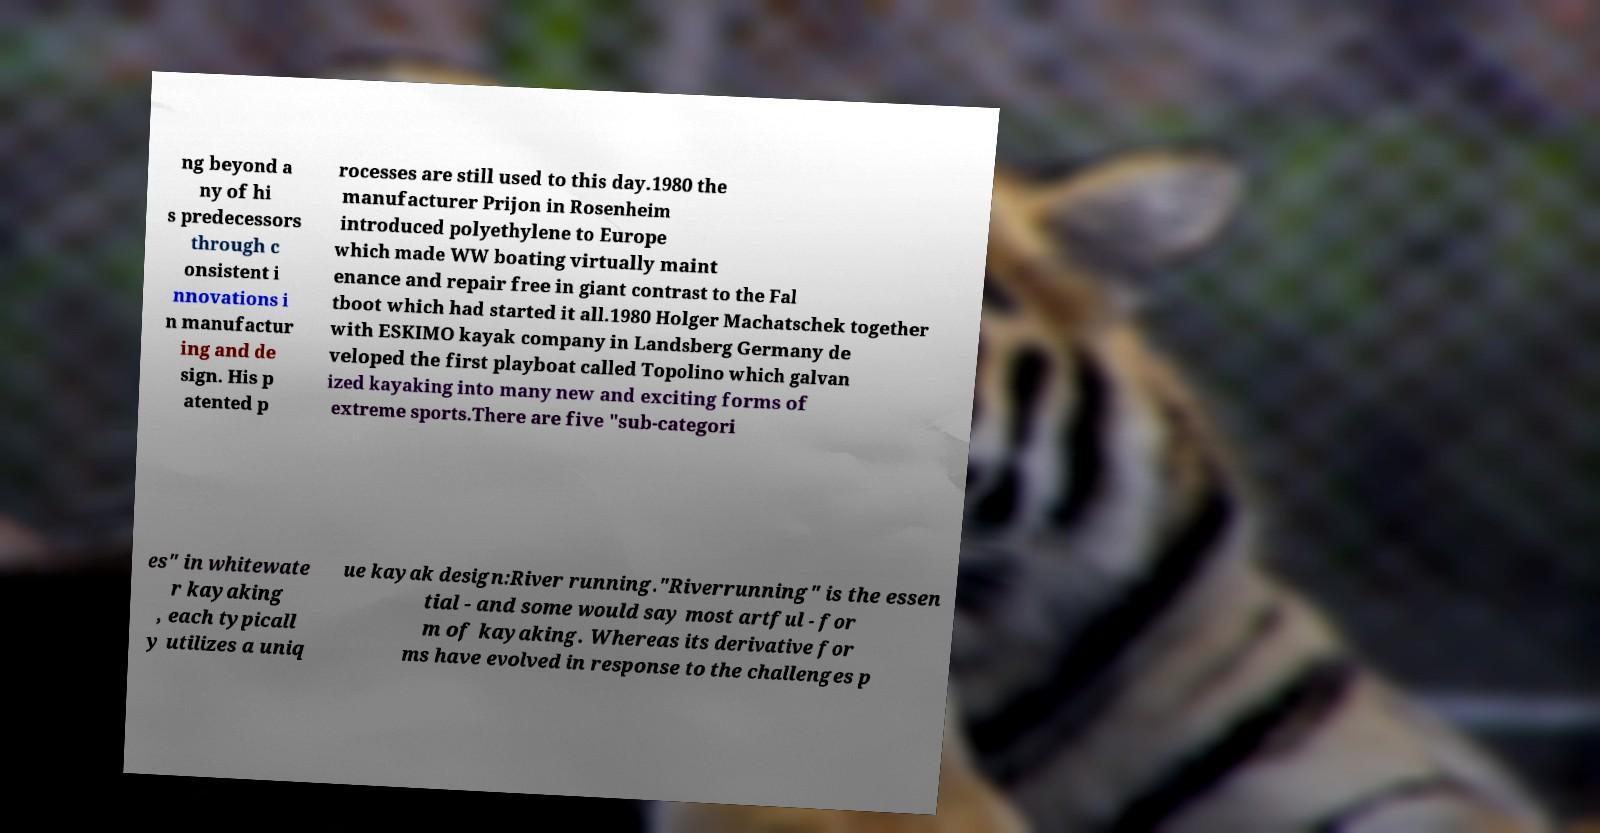What messages or text are displayed in this image? I need them in a readable, typed format. ng beyond a ny of hi s predecessors through c onsistent i nnovations i n manufactur ing and de sign. His p atented p rocesses are still used to this day.1980 the manufacturer Prijon in Rosenheim introduced polyethylene to Europe which made WW boating virtually maint enance and repair free in giant contrast to the Fal tboot which had started it all.1980 Holger Machatschek together with ESKIMO kayak company in Landsberg Germany de veloped the first playboat called Topolino which galvan ized kayaking into many new and exciting forms of extreme sports.There are five "sub-categori es" in whitewate r kayaking , each typicall y utilizes a uniq ue kayak design:River running."Riverrunning" is the essen tial - and some would say most artful - for m of kayaking. Whereas its derivative for ms have evolved in response to the challenges p 